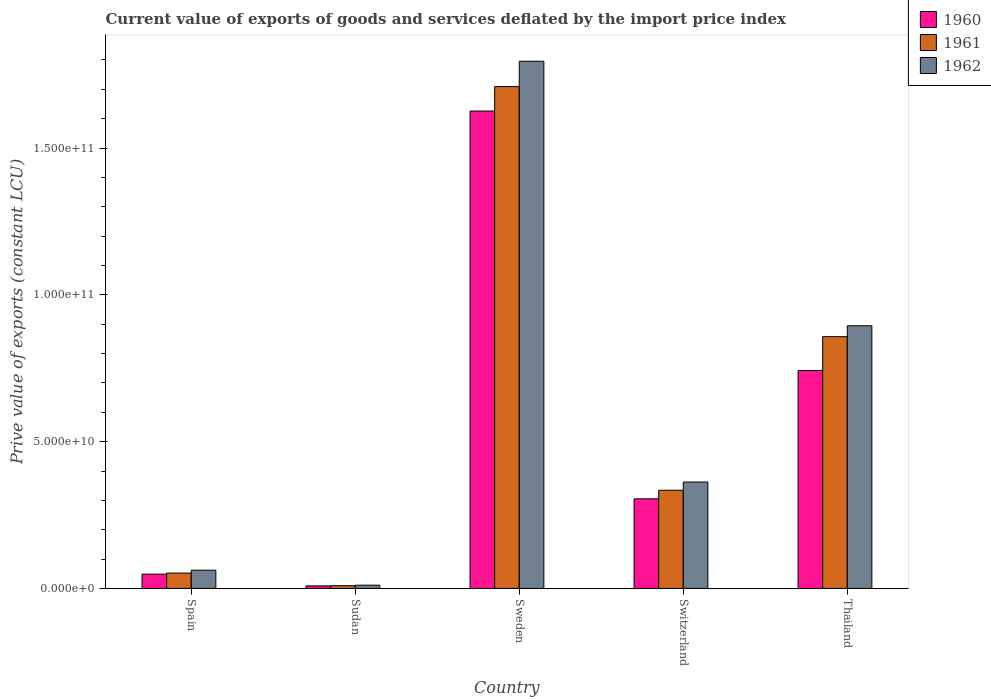How many groups of bars are there?
Give a very brief answer. 5. Are the number of bars per tick equal to the number of legend labels?
Keep it short and to the point. Yes. Are the number of bars on each tick of the X-axis equal?
Offer a terse response. Yes. How many bars are there on the 1st tick from the left?
Your answer should be very brief. 3. What is the prive value of exports in 1960 in Sweden?
Make the answer very short. 1.63e+11. Across all countries, what is the maximum prive value of exports in 1962?
Make the answer very short. 1.80e+11. Across all countries, what is the minimum prive value of exports in 1960?
Make the answer very short. 8.72e+08. In which country was the prive value of exports in 1962 maximum?
Give a very brief answer. Sweden. In which country was the prive value of exports in 1961 minimum?
Your answer should be very brief. Sudan. What is the total prive value of exports in 1960 in the graph?
Make the answer very short. 2.73e+11. What is the difference between the prive value of exports in 1962 in Spain and that in Switzerland?
Ensure brevity in your answer.  -3.00e+1. What is the difference between the prive value of exports in 1961 in Spain and the prive value of exports in 1960 in Sweden?
Make the answer very short. -1.57e+11. What is the average prive value of exports in 1962 per country?
Give a very brief answer. 6.25e+1. What is the difference between the prive value of exports of/in 1960 and prive value of exports of/in 1961 in Thailand?
Your answer should be very brief. -1.15e+1. What is the ratio of the prive value of exports in 1962 in Spain to that in Sweden?
Ensure brevity in your answer.  0.03. Is the difference between the prive value of exports in 1960 in Sudan and Thailand greater than the difference between the prive value of exports in 1961 in Sudan and Thailand?
Provide a succinct answer. Yes. What is the difference between the highest and the second highest prive value of exports in 1961?
Your answer should be very brief. 1.37e+11. What is the difference between the highest and the lowest prive value of exports in 1962?
Ensure brevity in your answer.  1.78e+11. Is the sum of the prive value of exports in 1962 in Sudan and Sweden greater than the maximum prive value of exports in 1960 across all countries?
Give a very brief answer. Yes. What does the 2nd bar from the left in Switzerland represents?
Offer a very short reply. 1961. Is it the case that in every country, the sum of the prive value of exports in 1962 and prive value of exports in 1960 is greater than the prive value of exports in 1961?
Offer a very short reply. Yes. How many countries are there in the graph?
Keep it short and to the point. 5. Are the values on the major ticks of Y-axis written in scientific E-notation?
Offer a very short reply. Yes. How many legend labels are there?
Your answer should be compact. 3. What is the title of the graph?
Provide a succinct answer. Current value of exports of goods and services deflated by the import price index. Does "1996" appear as one of the legend labels in the graph?
Give a very brief answer. No. What is the label or title of the Y-axis?
Your answer should be compact. Prive value of exports (constant LCU). What is the Prive value of exports (constant LCU) of 1960 in Spain?
Your response must be concise. 4.88e+09. What is the Prive value of exports (constant LCU) in 1961 in Spain?
Your response must be concise. 5.23e+09. What is the Prive value of exports (constant LCU) in 1962 in Spain?
Ensure brevity in your answer.  6.22e+09. What is the Prive value of exports (constant LCU) of 1960 in Sudan?
Keep it short and to the point. 8.72e+08. What is the Prive value of exports (constant LCU) in 1961 in Sudan?
Your answer should be very brief. 9.32e+08. What is the Prive value of exports (constant LCU) in 1962 in Sudan?
Your answer should be compact. 1.11e+09. What is the Prive value of exports (constant LCU) in 1960 in Sweden?
Provide a short and direct response. 1.63e+11. What is the Prive value of exports (constant LCU) in 1961 in Sweden?
Offer a terse response. 1.71e+11. What is the Prive value of exports (constant LCU) in 1962 in Sweden?
Keep it short and to the point. 1.80e+11. What is the Prive value of exports (constant LCU) of 1960 in Switzerland?
Provide a succinct answer. 3.05e+1. What is the Prive value of exports (constant LCU) in 1961 in Switzerland?
Ensure brevity in your answer.  3.34e+1. What is the Prive value of exports (constant LCU) of 1962 in Switzerland?
Offer a terse response. 3.62e+1. What is the Prive value of exports (constant LCU) in 1960 in Thailand?
Make the answer very short. 7.42e+1. What is the Prive value of exports (constant LCU) of 1961 in Thailand?
Provide a short and direct response. 8.58e+1. What is the Prive value of exports (constant LCU) of 1962 in Thailand?
Your answer should be compact. 8.95e+1. Across all countries, what is the maximum Prive value of exports (constant LCU) of 1960?
Your answer should be compact. 1.63e+11. Across all countries, what is the maximum Prive value of exports (constant LCU) in 1961?
Give a very brief answer. 1.71e+11. Across all countries, what is the maximum Prive value of exports (constant LCU) in 1962?
Your answer should be very brief. 1.80e+11. Across all countries, what is the minimum Prive value of exports (constant LCU) of 1960?
Make the answer very short. 8.72e+08. Across all countries, what is the minimum Prive value of exports (constant LCU) in 1961?
Offer a very short reply. 9.32e+08. Across all countries, what is the minimum Prive value of exports (constant LCU) in 1962?
Make the answer very short. 1.11e+09. What is the total Prive value of exports (constant LCU) in 1960 in the graph?
Your answer should be compact. 2.73e+11. What is the total Prive value of exports (constant LCU) in 1961 in the graph?
Offer a very short reply. 2.96e+11. What is the total Prive value of exports (constant LCU) in 1962 in the graph?
Give a very brief answer. 3.13e+11. What is the difference between the Prive value of exports (constant LCU) in 1960 in Spain and that in Sudan?
Give a very brief answer. 4.00e+09. What is the difference between the Prive value of exports (constant LCU) of 1961 in Spain and that in Sudan?
Offer a terse response. 4.29e+09. What is the difference between the Prive value of exports (constant LCU) of 1962 in Spain and that in Sudan?
Your answer should be very brief. 5.11e+09. What is the difference between the Prive value of exports (constant LCU) in 1960 in Spain and that in Sweden?
Your answer should be compact. -1.58e+11. What is the difference between the Prive value of exports (constant LCU) of 1961 in Spain and that in Sweden?
Your answer should be compact. -1.66e+11. What is the difference between the Prive value of exports (constant LCU) of 1962 in Spain and that in Sweden?
Offer a very short reply. -1.73e+11. What is the difference between the Prive value of exports (constant LCU) of 1960 in Spain and that in Switzerland?
Make the answer very short. -2.56e+1. What is the difference between the Prive value of exports (constant LCU) in 1961 in Spain and that in Switzerland?
Give a very brief answer. -2.82e+1. What is the difference between the Prive value of exports (constant LCU) in 1962 in Spain and that in Switzerland?
Give a very brief answer. -3.00e+1. What is the difference between the Prive value of exports (constant LCU) of 1960 in Spain and that in Thailand?
Offer a very short reply. -6.94e+1. What is the difference between the Prive value of exports (constant LCU) of 1961 in Spain and that in Thailand?
Make the answer very short. -8.05e+1. What is the difference between the Prive value of exports (constant LCU) of 1962 in Spain and that in Thailand?
Provide a succinct answer. -8.32e+1. What is the difference between the Prive value of exports (constant LCU) of 1960 in Sudan and that in Sweden?
Provide a succinct answer. -1.62e+11. What is the difference between the Prive value of exports (constant LCU) in 1961 in Sudan and that in Sweden?
Your answer should be very brief. -1.70e+11. What is the difference between the Prive value of exports (constant LCU) of 1962 in Sudan and that in Sweden?
Make the answer very short. -1.78e+11. What is the difference between the Prive value of exports (constant LCU) in 1960 in Sudan and that in Switzerland?
Your response must be concise. -2.96e+1. What is the difference between the Prive value of exports (constant LCU) of 1961 in Sudan and that in Switzerland?
Your answer should be compact. -3.25e+1. What is the difference between the Prive value of exports (constant LCU) in 1962 in Sudan and that in Switzerland?
Offer a terse response. -3.51e+1. What is the difference between the Prive value of exports (constant LCU) of 1960 in Sudan and that in Thailand?
Give a very brief answer. -7.34e+1. What is the difference between the Prive value of exports (constant LCU) of 1961 in Sudan and that in Thailand?
Your answer should be very brief. -8.48e+1. What is the difference between the Prive value of exports (constant LCU) in 1962 in Sudan and that in Thailand?
Make the answer very short. -8.84e+1. What is the difference between the Prive value of exports (constant LCU) in 1960 in Sweden and that in Switzerland?
Your answer should be compact. 1.32e+11. What is the difference between the Prive value of exports (constant LCU) of 1961 in Sweden and that in Switzerland?
Offer a terse response. 1.37e+11. What is the difference between the Prive value of exports (constant LCU) in 1962 in Sweden and that in Switzerland?
Offer a terse response. 1.43e+11. What is the difference between the Prive value of exports (constant LCU) in 1960 in Sweden and that in Thailand?
Give a very brief answer. 8.84e+1. What is the difference between the Prive value of exports (constant LCU) of 1961 in Sweden and that in Thailand?
Provide a short and direct response. 8.52e+1. What is the difference between the Prive value of exports (constant LCU) in 1962 in Sweden and that in Thailand?
Provide a short and direct response. 9.01e+1. What is the difference between the Prive value of exports (constant LCU) in 1960 in Switzerland and that in Thailand?
Offer a terse response. -4.37e+1. What is the difference between the Prive value of exports (constant LCU) of 1961 in Switzerland and that in Thailand?
Your answer should be very brief. -5.23e+1. What is the difference between the Prive value of exports (constant LCU) of 1962 in Switzerland and that in Thailand?
Your answer should be compact. -5.32e+1. What is the difference between the Prive value of exports (constant LCU) of 1960 in Spain and the Prive value of exports (constant LCU) of 1961 in Sudan?
Offer a very short reply. 3.95e+09. What is the difference between the Prive value of exports (constant LCU) of 1960 in Spain and the Prive value of exports (constant LCU) of 1962 in Sudan?
Provide a succinct answer. 3.77e+09. What is the difference between the Prive value of exports (constant LCU) of 1961 in Spain and the Prive value of exports (constant LCU) of 1962 in Sudan?
Your response must be concise. 4.11e+09. What is the difference between the Prive value of exports (constant LCU) in 1960 in Spain and the Prive value of exports (constant LCU) in 1961 in Sweden?
Your answer should be very brief. -1.66e+11. What is the difference between the Prive value of exports (constant LCU) of 1960 in Spain and the Prive value of exports (constant LCU) of 1962 in Sweden?
Your answer should be very brief. -1.75e+11. What is the difference between the Prive value of exports (constant LCU) of 1961 in Spain and the Prive value of exports (constant LCU) of 1962 in Sweden?
Provide a short and direct response. -1.74e+11. What is the difference between the Prive value of exports (constant LCU) of 1960 in Spain and the Prive value of exports (constant LCU) of 1961 in Switzerland?
Offer a terse response. -2.86e+1. What is the difference between the Prive value of exports (constant LCU) of 1960 in Spain and the Prive value of exports (constant LCU) of 1962 in Switzerland?
Your answer should be compact. -3.14e+1. What is the difference between the Prive value of exports (constant LCU) in 1961 in Spain and the Prive value of exports (constant LCU) in 1962 in Switzerland?
Ensure brevity in your answer.  -3.10e+1. What is the difference between the Prive value of exports (constant LCU) in 1960 in Spain and the Prive value of exports (constant LCU) in 1961 in Thailand?
Your answer should be compact. -8.09e+1. What is the difference between the Prive value of exports (constant LCU) of 1960 in Spain and the Prive value of exports (constant LCU) of 1962 in Thailand?
Give a very brief answer. -8.46e+1. What is the difference between the Prive value of exports (constant LCU) in 1961 in Spain and the Prive value of exports (constant LCU) in 1962 in Thailand?
Offer a very short reply. -8.42e+1. What is the difference between the Prive value of exports (constant LCU) in 1960 in Sudan and the Prive value of exports (constant LCU) in 1961 in Sweden?
Ensure brevity in your answer.  -1.70e+11. What is the difference between the Prive value of exports (constant LCU) in 1960 in Sudan and the Prive value of exports (constant LCU) in 1962 in Sweden?
Provide a short and direct response. -1.79e+11. What is the difference between the Prive value of exports (constant LCU) of 1961 in Sudan and the Prive value of exports (constant LCU) of 1962 in Sweden?
Offer a terse response. -1.79e+11. What is the difference between the Prive value of exports (constant LCU) in 1960 in Sudan and the Prive value of exports (constant LCU) in 1961 in Switzerland?
Give a very brief answer. -3.26e+1. What is the difference between the Prive value of exports (constant LCU) in 1960 in Sudan and the Prive value of exports (constant LCU) in 1962 in Switzerland?
Your response must be concise. -3.54e+1. What is the difference between the Prive value of exports (constant LCU) of 1961 in Sudan and the Prive value of exports (constant LCU) of 1962 in Switzerland?
Provide a succinct answer. -3.53e+1. What is the difference between the Prive value of exports (constant LCU) in 1960 in Sudan and the Prive value of exports (constant LCU) in 1961 in Thailand?
Your answer should be compact. -8.49e+1. What is the difference between the Prive value of exports (constant LCU) of 1960 in Sudan and the Prive value of exports (constant LCU) of 1962 in Thailand?
Make the answer very short. -8.86e+1. What is the difference between the Prive value of exports (constant LCU) of 1961 in Sudan and the Prive value of exports (constant LCU) of 1962 in Thailand?
Offer a terse response. -8.85e+1. What is the difference between the Prive value of exports (constant LCU) of 1960 in Sweden and the Prive value of exports (constant LCU) of 1961 in Switzerland?
Your answer should be compact. 1.29e+11. What is the difference between the Prive value of exports (constant LCU) of 1960 in Sweden and the Prive value of exports (constant LCU) of 1962 in Switzerland?
Ensure brevity in your answer.  1.26e+11. What is the difference between the Prive value of exports (constant LCU) of 1961 in Sweden and the Prive value of exports (constant LCU) of 1962 in Switzerland?
Offer a terse response. 1.35e+11. What is the difference between the Prive value of exports (constant LCU) in 1960 in Sweden and the Prive value of exports (constant LCU) in 1961 in Thailand?
Give a very brief answer. 7.69e+1. What is the difference between the Prive value of exports (constant LCU) of 1960 in Sweden and the Prive value of exports (constant LCU) of 1962 in Thailand?
Give a very brief answer. 7.31e+1. What is the difference between the Prive value of exports (constant LCU) in 1961 in Sweden and the Prive value of exports (constant LCU) in 1962 in Thailand?
Ensure brevity in your answer.  8.15e+1. What is the difference between the Prive value of exports (constant LCU) in 1960 in Switzerland and the Prive value of exports (constant LCU) in 1961 in Thailand?
Your answer should be very brief. -5.52e+1. What is the difference between the Prive value of exports (constant LCU) in 1960 in Switzerland and the Prive value of exports (constant LCU) in 1962 in Thailand?
Offer a terse response. -5.89e+1. What is the difference between the Prive value of exports (constant LCU) in 1961 in Switzerland and the Prive value of exports (constant LCU) in 1962 in Thailand?
Keep it short and to the point. -5.60e+1. What is the average Prive value of exports (constant LCU) of 1960 per country?
Offer a terse response. 5.46e+1. What is the average Prive value of exports (constant LCU) of 1961 per country?
Offer a very short reply. 5.93e+1. What is the average Prive value of exports (constant LCU) in 1962 per country?
Offer a very short reply. 6.25e+1. What is the difference between the Prive value of exports (constant LCU) of 1960 and Prive value of exports (constant LCU) of 1961 in Spain?
Provide a short and direct response. -3.48e+08. What is the difference between the Prive value of exports (constant LCU) in 1960 and Prive value of exports (constant LCU) in 1962 in Spain?
Provide a succinct answer. -1.34e+09. What is the difference between the Prive value of exports (constant LCU) of 1961 and Prive value of exports (constant LCU) of 1962 in Spain?
Provide a short and direct response. -9.94e+08. What is the difference between the Prive value of exports (constant LCU) of 1960 and Prive value of exports (constant LCU) of 1961 in Sudan?
Keep it short and to the point. -5.96e+07. What is the difference between the Prive value of exports (constant LCU) in 1960 and Prive value of exports (constant LCU) in 1962 in Sudan?
Provide a short and direct response. -2.38e+08. What is the difference between the Prive value of exports (constant LCU) in 1961 and Prive value of exports (constant LCU) in 1962 in Sudan?
Offer a terse response. -1.79e+08. What is the difference between the Prive value of exports (constant LCU) of 1960 and Prive value of exports (constant LCU) of 1961 in Sweden?
Give a very brief answer. -8.32e+09. What is the difference between the Prive value of exports (constant LCU) of 1960 and Prive value of exports (constant LCU) of 1962 in Sweden?
Your answer should be compact. -1.70e+1. What is the difference between the Prive value of exports (constant LCU) in 1961 and Prive value of exports (constant LCU) in 1962 in Sweden?
Offer a very short reply. -8.64e+09. What is the difference between the Prive value of exports (constant LCU) of 1960 and Prive value of exports (constant LCU) of 1961 in Switzerland?
Your answer should be very brief. -2.93e+09. What is the difference between the Prive value of exports (constant LCU) of 1960 and Prive value of exports (constant LCU) of 1962 in Switzerland?
Make the answer very short. -5.72e+09. What is the difference between the Prive value of exports (constant LCU) in 1961 and Prive value of exports (constant LCU) in 1962 in Switzerland?
Make the answer very short. -2.79e+09. What is the difference between the Prive value of exports (constant LCU) in 1960 and Prive value of exports (constant LCU) in 1961 in Thailand?
Keep it short and to the point. -1.15e+1. What is the difference between the Prive value of exports (constant LCU) of 1960 and Prive value of exports (constant LCU) of 1962 in Thailand?
Your answer should be compact. -1.52e+1. What is the difference between the Prive value of exports (constant LCU) of 1961 and Prive value of exports (constant LCU) of 1962 in Thailand?
Give a very brief answer. -3.71e+09. What is the ratio of the Prive value of exports (constant LCU) of 1960 in Spain to that in Sudan?
Your answer should be compact. 5.59. What is the ratio of the Prive value of exports (constant LCU) in 1961 in Spain to that in Sudan?
Your response must be concise. 5.61. What is the ratio of the Prive value of exports (constant LCU) in 1962 in Spain to that in Sudan?
Make the answer very short. 5.6. What is the ratio of the Prive value of exports (constant LCU) of 1960 in Spain to that in Sweden?
Offer a very short reply. 0.03. What is the ratio of the Prive value of exports (constant LCU) of 1961 in Spain to that in Sweden?
Keep it short and to the point. 0.03. What is the ratio of the Prive value of exports (constant LCU) in 1962 in Spain to that in Sweden?
Offer a very short reply. 0.03. What is the ratio of the Prive value of exports (constant LCU) of 1960 in Spain to that in Switzerland?
Your answer should be compact. 0.16. What is the ratio of the Prive value of exports (constant LCU) in 1961 in Spain to that in Switzerland?
Your response must be concise. 0.16. What is the ratio of the Prive value of exports (constant LCU) in 1962 in Spain to that in Switzerland?
Your answer should be very brief. 0.17. What is the ratio of the Prive value of exports (constant LCU) of 1960 in Spain to that in Thailand?
Your response must be concise. 0.07. What is the ratio of the Prive value of exports (constant LCU) of 1961 in Spain to that in Thailand?
Your answer should be compact. 0.06. What is the ratio of the Prive value of exports (constant LCU) of 1962 in Spain to that in Thailand?
Offer a terse response. 0.07. What is the ratio of the Prive value of exports (constant LCU) in 1960 in Sudan to that in Sweden?
Give a very brief answer. 0.01. What is the ratio of the Prive value of exports (constant LCU) of 1961 in Sudan to that in Sweden?
Provide a succinct answer. 0.01. What is the ratio of the Prive value of exports (constant LCU) of 1962 in Sudan to that in Sweden?
Provide a short and direct response. 0.01. What is the ratio of the Prive value of exports (constant LCU) in 1960 in Sudan to that in Switzerland?
Make the answer very short. 0.03. What is the ratio of the Prive value of exports (constant LCU) in 1961 in Sudan to that in Switzerland?
Your answer should be compact. 0.03. What is the ratio of the Prive value of exports (constant LCU) in 1962 in Sudan to that in Switzerland?
Ensure brevity in your answer.  0.03. What is the ratio of the Prive value of exports (constant LCU) in 1960 in Sudan to that in Thailand?
Your answer should be compact. 0.01. What is the ratio of the Prive value of exports (constant LCU) of 1961 in Sudan to that in Thailand?
Keep it short and to the point. 0.01. What is the ratio of the Prive value of exports (constant LCU) in 1962 in Sudan to that in Thailand?
Keep it short and to the point. 0.01. What is the ratio of the Prive value of exports (constant LCU) of 1960 in Sweden to that in Switzerland?
Ensure brevity in your answer.  5.33. What is the ratio of the Prive value of exports (constant LCU) in 1961 in Sweden to that in Switzerland?
Your answer should be very brief. 5.11. What is the ratio of the Prive value of exports (constant LCU) of 1962 in Sweden to that in Switzerland?
Give a very brief answer. 4.96. What is the ratio of the Prive value of exports (constant LCU) of 1960 in Sweden to that in Thailand?
Ensure brevity in your answer.  2.19. What is the ratio of the Prive value of exports (constant LCU) of 1961 in Sweden to that in Thailand?
Provide a succinct answer. 1.99. What is the ratio of the Prive value of exports (constant LCU) of 1962 in Sweden to that in Thailand?
Your answer should be very brief. 2.01. What is the ratio of the Prive value of exports (constant LCU) in 1960 in Switzerland to that in Thailand?
Make the answer very short. 0.41. What is the ratio of the Prive value of exports (constant LCU) of 1961 in Switzerland to that in Thailand?
Your answer should be very brief. 0.39. What is the ratio of the Prive value of exports (constant LCU) in 1962 in Switzerland to that in Thailand?
Provide a short and direct response. 0.41. What is the difference between the highest and the second highest Prive value of exports (constant LCU) of 1960?
Your response must be concise. 8.84e+1. What is the difference between the highest and the second highest Prive value of exports (constant LCU) in 1961?
Give a very brief answer. 8.52e+1. What is the difference between the highest and the second highest Prive value of exports (constant LCU) of 1962?
Ensure brevity in your answer.  9.01e+1. What is the difference between the highest and the lowest Prive value of exports (constant LCU) of 1960?
Provide a short and direct response. 1.62e+11. What is the difference between the highest and the lowest Prive value of exports (constant LCU) of 1961?
Keep it short and to the point. 1.70e+11. What is the difference between the highest and the lowest Prive value of exports (constant LCU) in 1962?
Provide a succinct answer. 1.78e+11. 